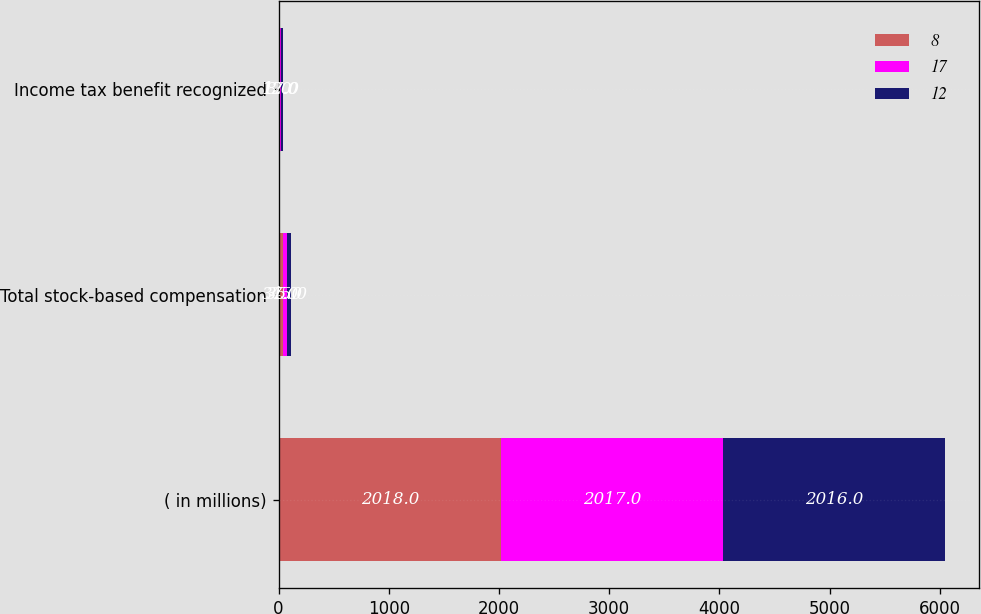Convert chart to OTSL. <chart><loc_0><loc_0><loc_500><loc_500><stacked_bar_chart><ecel><fcel>( in millions)<fcel>Total stock-based compensation<fcel>Income tax benefit recognized<nl><fcel>8<fcel>2018<fcel>37<fcel>8<nl><fcel>17<fcel>2017<fcel>35<fcel>12<nl><fcel>12<fcel>2016<fcel>45<fcel>17<nl></chart> 